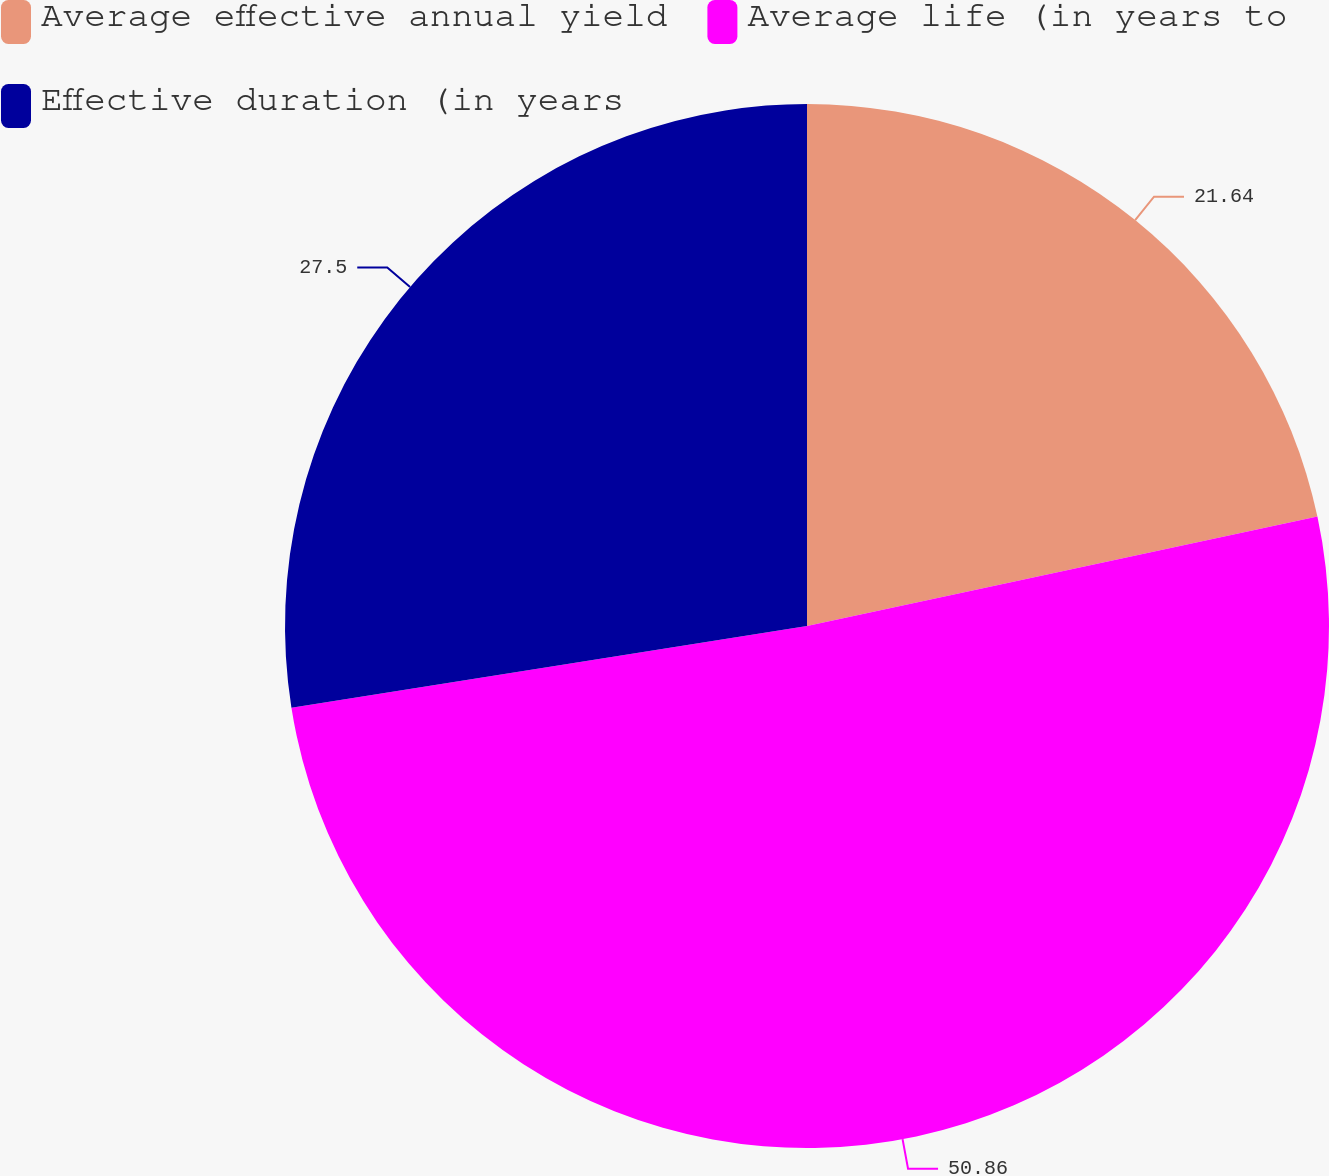Convert chart to OTSL. <chart><loc_0><loc_0><loc_500><loc_500><pie_chart><fcel>Average effective annual yield<fcel>Average life (in years to<fcel>Effective duration (in years<nl><fcel>21.64%<fcel>50.86%<fcel>27.5%<nl></chart> 